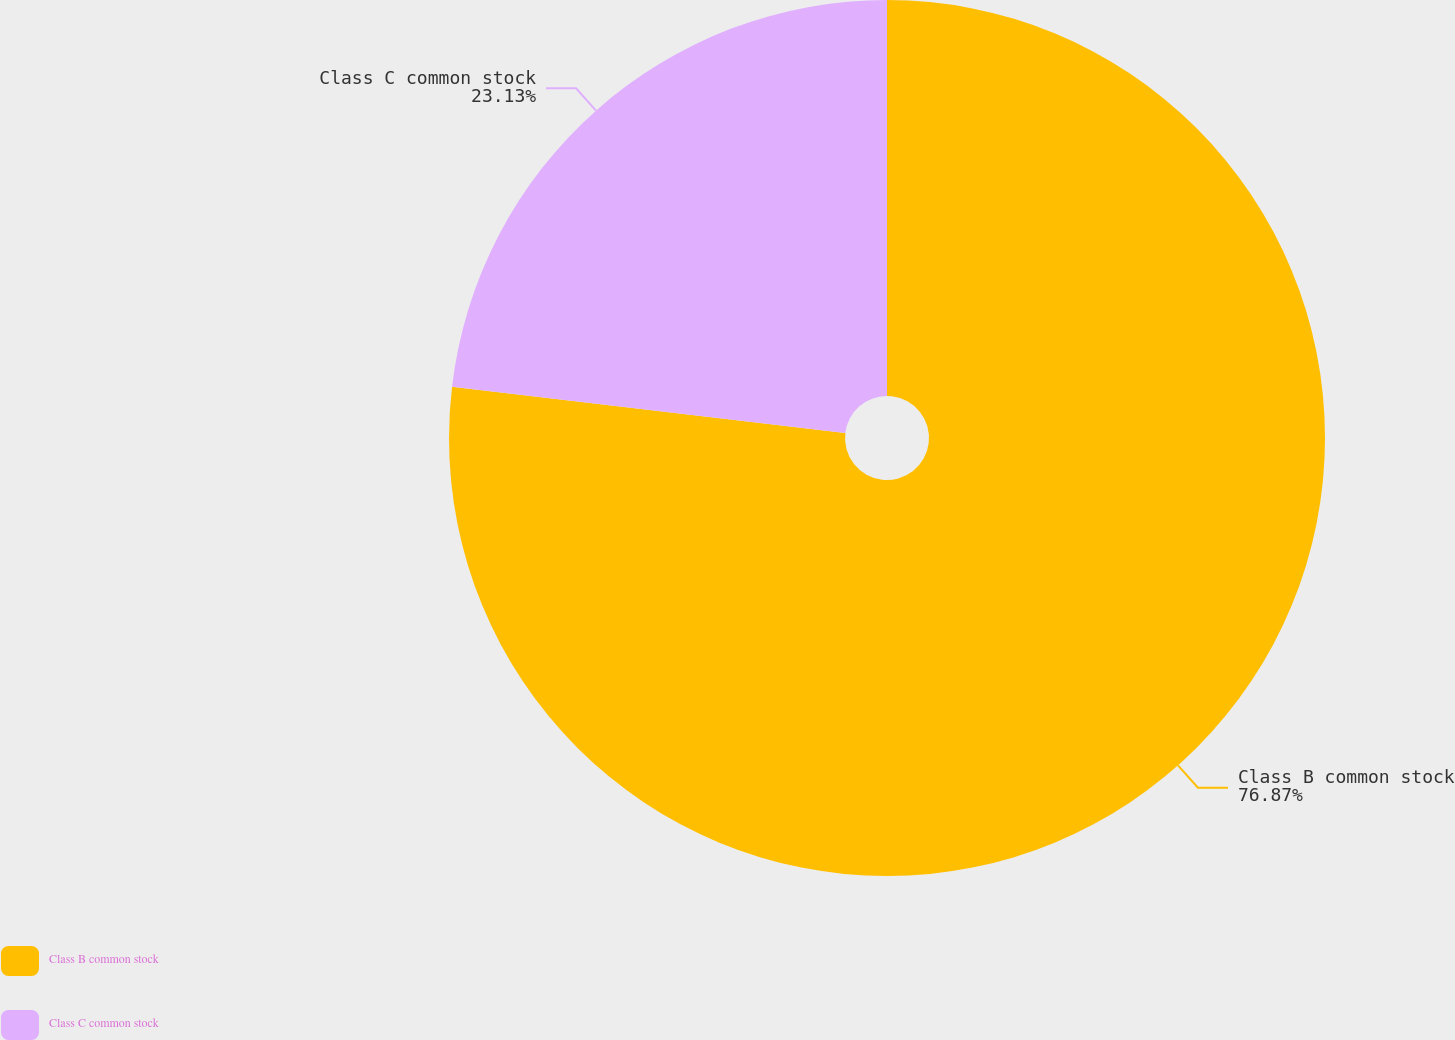Convert chart. <chart><loc_0><loc_0><loc_500><loc_500><pie_chart><fcel>Class B common stock<fcel>Class C common stock<nl><fcel>76.87%<fcel>23.13%<nl></chart> 